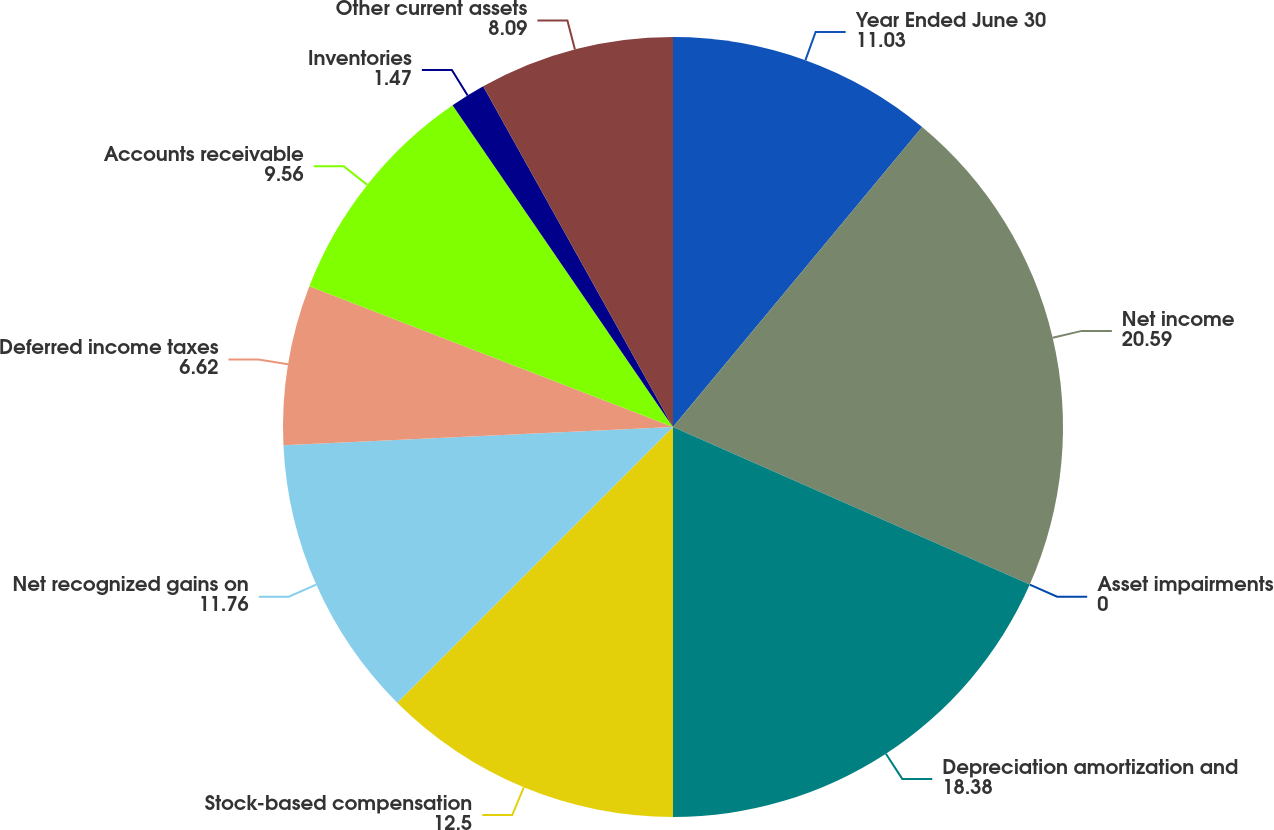Convert chart to OTSL. <chart><loc_0><loc_0><loc_500><loc_500><pie_chart><fcel>Year Ended June 30<fcel>Net income<fcel>Asset impairments<fcel>Depreciation amortization and<fcel>Stock-based compensation<fcel>Net recognized gains on<fcel>Deferred income taxes<fcel>Accounts receivable<fcel>Inventories<fcel>Other current assets<nl><fcel>11.03%<fcel>20.59%<fcel>0.0%<fcel>18.38%<fcel>12.5%<fcel>11.76%<fcel>6.62%<fcel>9.56%<fcel>1.47%<fcel>8.09%<nl></chart> 